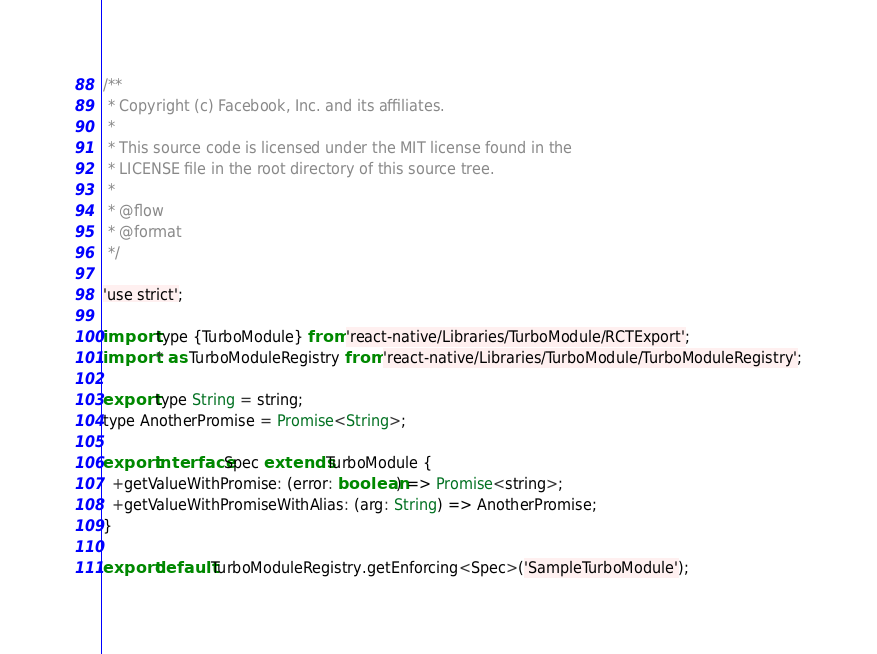<code> <loc_0><loc_0><loc_500><loc_500><_JavaScript_>/**
 * Copyright (c) Facebook, Inc. and its affiliates.
 *
 * This source code is licensed under the MIT license found in the
 * LICENSE file in the root directory of this source tree.
 *
 * @flow
 * @format
 */

'use strict';

import type {TurboModule} from 'react-native/Libraries/TurboModule/RCTExport';
import * as TurboModuleRegistry from 'react-native/Libraries/TurboModule/TurboModuleRegistry';

export type String = string;
type AnotherPromise = Promise<String>;

export interface Spec extends TurboModule {
  +getValueWithPromise: (error: boolean) => Promise<string>;
  +getValueWithPromiseWithAlias: (arg: String) => AnotherPromise;
}

export default TurboModuleRegistry.getEnforcing<Spec>('SampleTurboModule');
</code> 